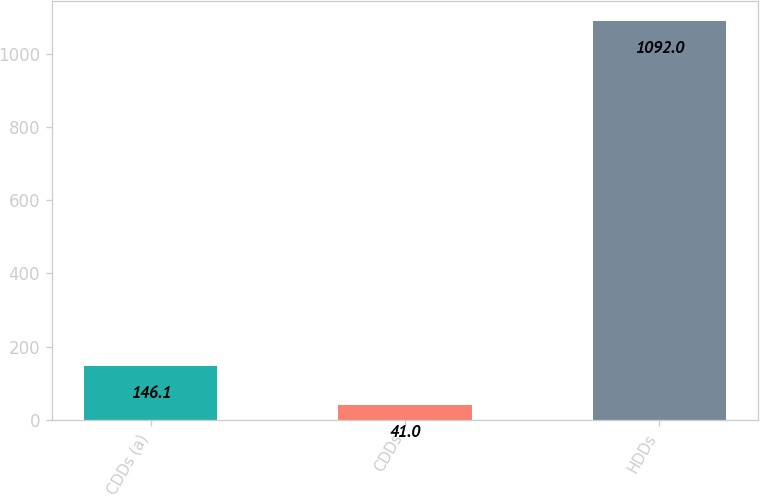<chart> <loc_0><loc_0><loc_500><loc_500><bar_chart><fcel>CDDs (a)<fcel>CDDs<fcel>HDDs<nl><fcel>146.1<fcel>41<fcel>1092<nl></chart> 